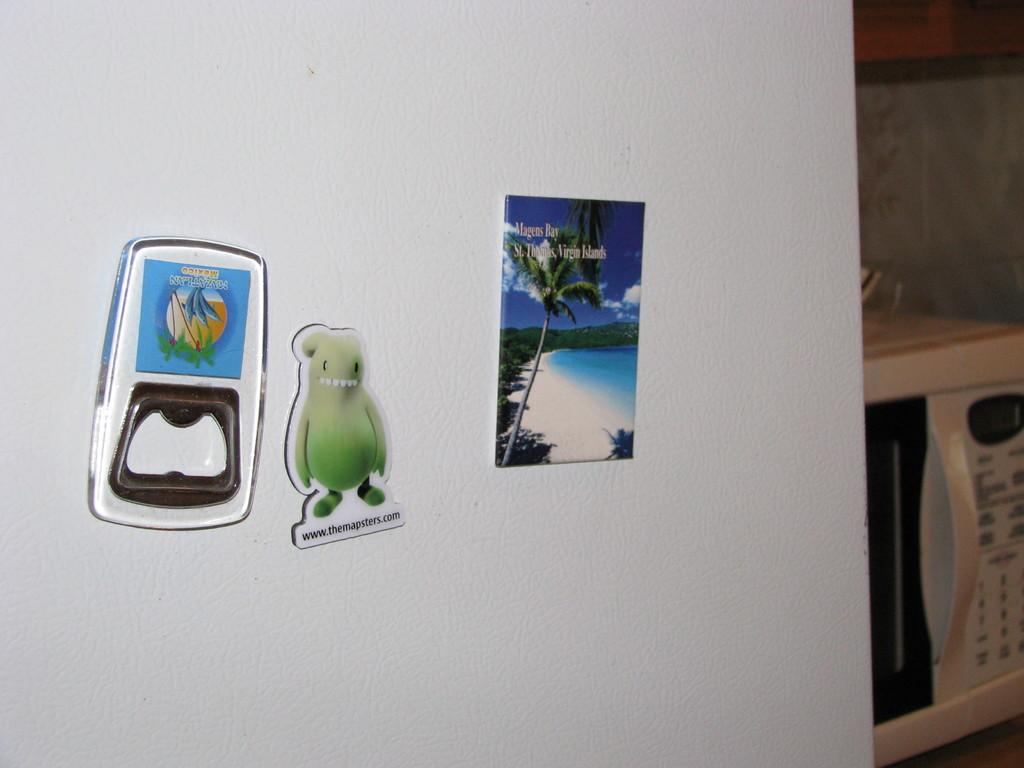What type of objects can be seen on the table in the image? There is a microwave oven on a table in the image. What else is present in the image besides the microwave oven? There are stickers present in the image. What type of zebra can be seen at the party in the image? There is no zebra or party present in the image; it only features a microwave oven and stickers. 